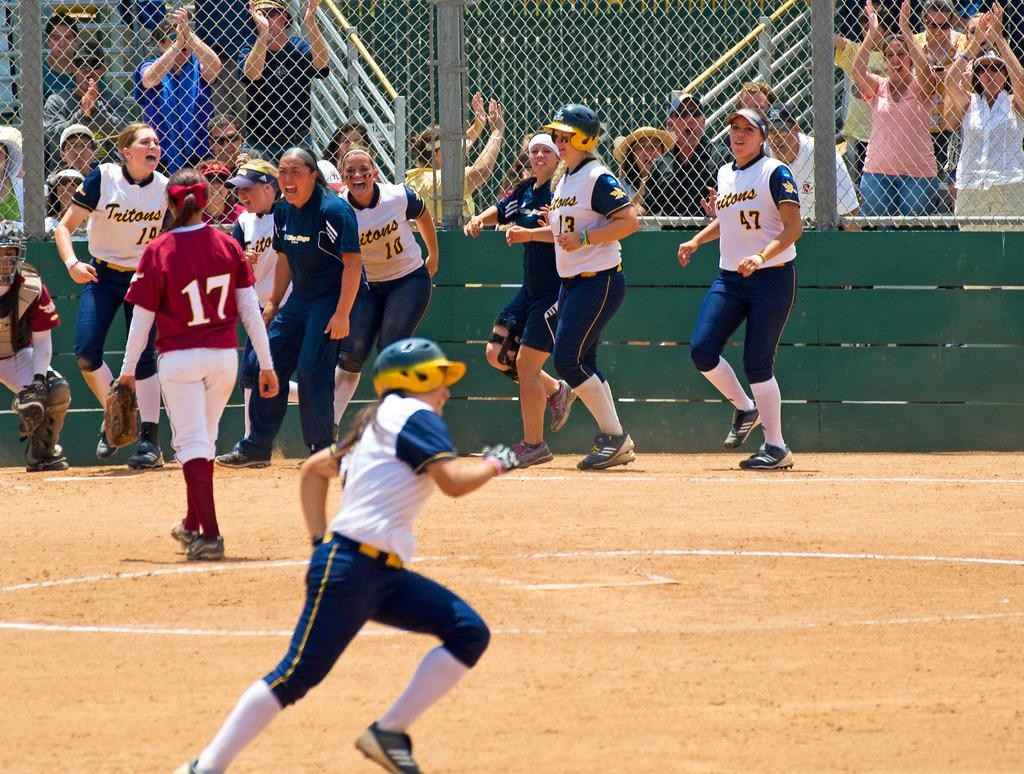What are the people in the image wearing? The people in the image are wearing sports dress. What are the people in the image doing? The people appear to be playing. What can be seen in the background of the image? There is a fence in the image, and people in a stadium are visible in the background. Can you see any icicles hanging from the fence in the image? There are no icicles visible in the image; the weather appears to be suitable for outdoor sports. What act are the people in the image performing? The people in the image are playing a sport, but we cannot determine the specific act or performance from the image. 